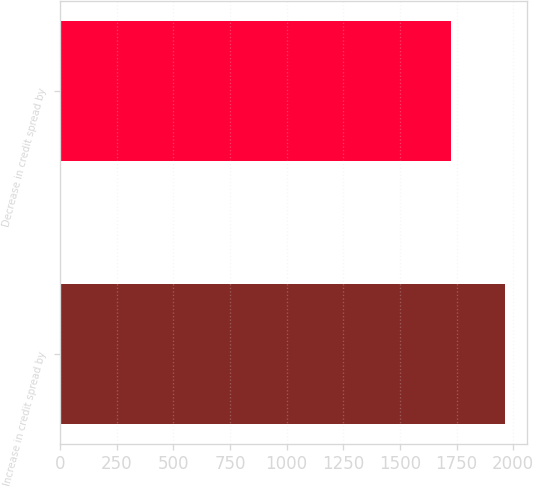<chart> <loc_0><loc_0><loc_500><loc_500><bar_chart><fcel>Increase in credit spread by<fcel>Decrease in credit spread by<nl><fcel>1964<fcel>1726<nl></chart> 